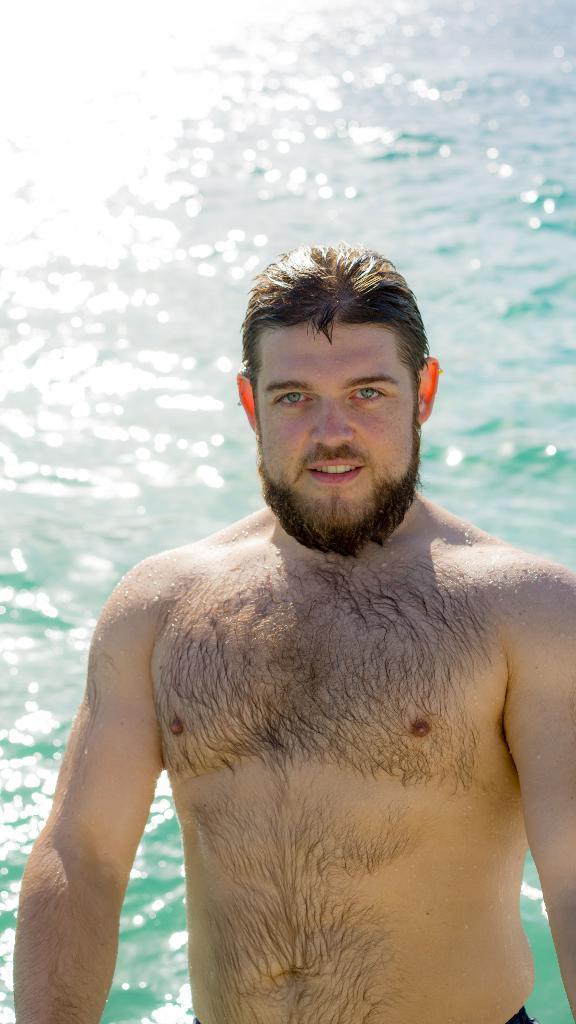What is present in the image? There is a man in the image. What can be seen in the background of the image? There is water visible in the background of the image. What type of rock is the man holding in the image? There is no rock present in the image; it only features a man and water in the background. 